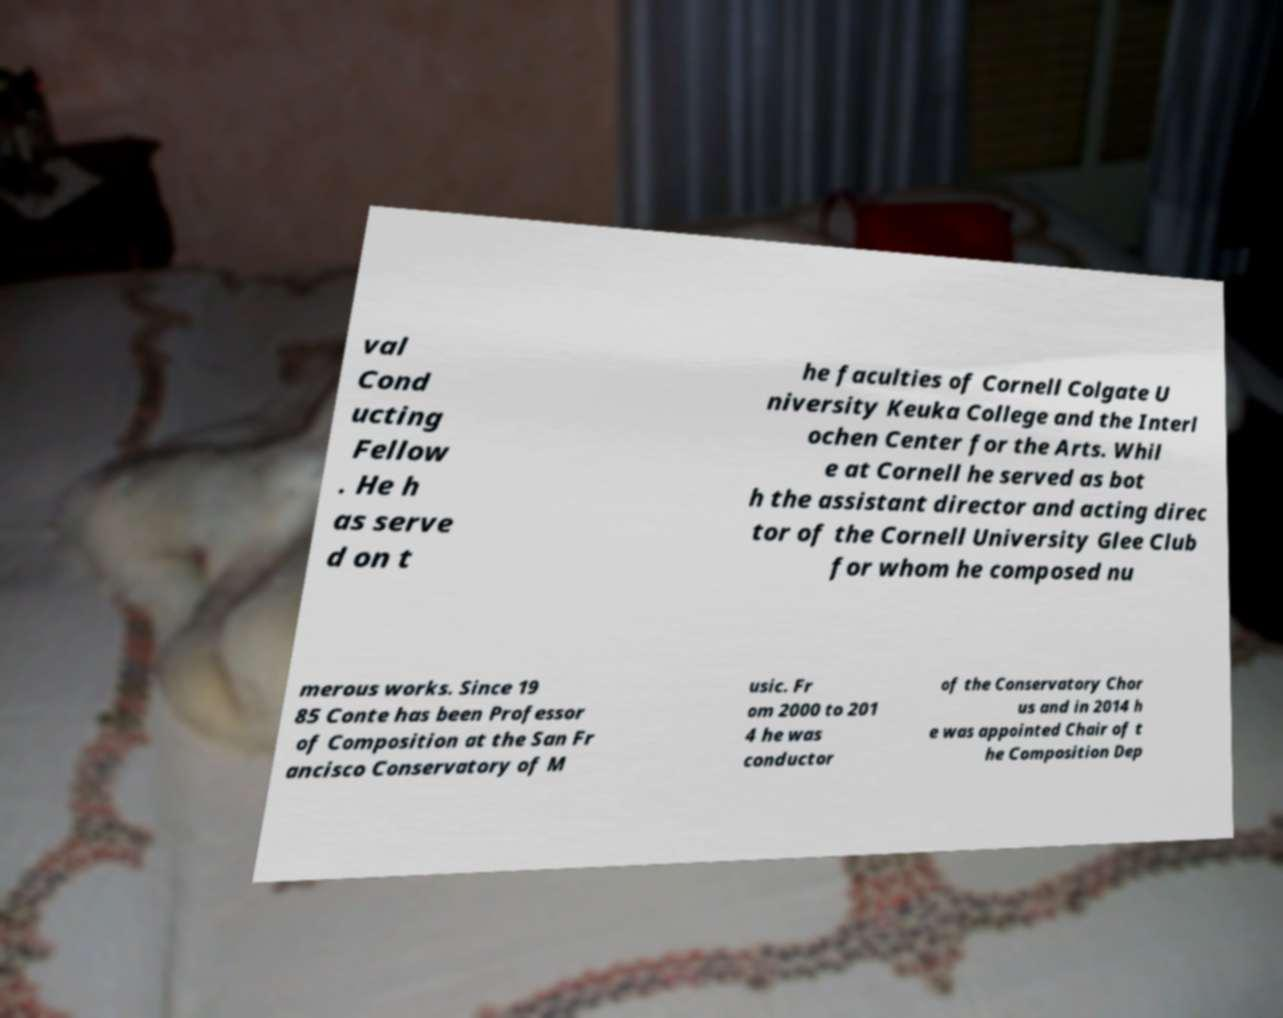Could you extract and type out the text from this image? val Cond ucting Fellow . He h as serve d on t he faculties of Cornell Colgate U niversity Keuka College and the Interl ochen Center for the Arts. Whil e at Cornell he served as bot h the assistant director and acting direc tor of the Cornell University Glee Club for whom he composed nu merous works. Since 19 85 Conte has been Professor of Composition at the San Fr ancisco Conservatory of M usic. Fr om 2000 to 201 4 he was conductor of the Conservatory Chor us and in 2014 h e was appointed Chair of t he Composition Dep 